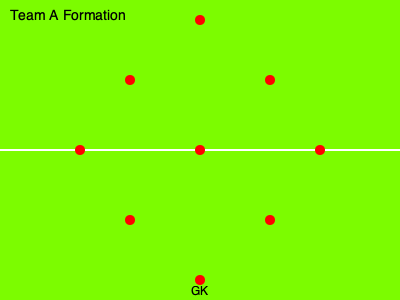Based on the tactical formation diagram shown, which successful Bundesliga team's preferred playing style does this most likely represent, and what potential advantages does this system offer in the context of modern German football? To answer this question, let's analyze the formation step-by-step:

1. The diagram shows a 4-3-2-1 formation, also known as the "Christmas Tree" formation.

2. This formation is characterized by:
   - Four defenders in a line
   - Three central midfielders
   - Two attacking midfielders
   - One striker

3. In the Bundesliga, this formation has been most notably used by Eintracht Frankfurt, especially during their successful 2018-2019 season under Adi Hütter.

4. Advantages of this system in modern German football:
   a) Defensive stability: The four-man backline provides a solid defensive foundation.
   b) Midfield control: Three central midfielders allow for better ball possession and control of the game's tempo.
   c) Flexibility in attack: The two attacking midfielders can support the lone striker or drop back to assist in midfield.
   d) Width through full-backs: With no natural wingers, the full-backs are encouraged to provide width in attack.
   e) Pressing: This formation allows for effective high pressing, a key aspect of modern German football.

5. Eintracht Frankfurt's success with this formation led them to a 7th place finish in the 2018-2019 Bundesliga and helped them reach the semi-finals of the UEFA Europa League.

6. The formation suits teams with strong, technically gifted midfielders and versatile attacking players, which aligns with the style of play often seen in successful Bundesliga teams.
Answer: Eintracht Frankfurt; offers midfield control, defensive stability, and flexible attacking options. 